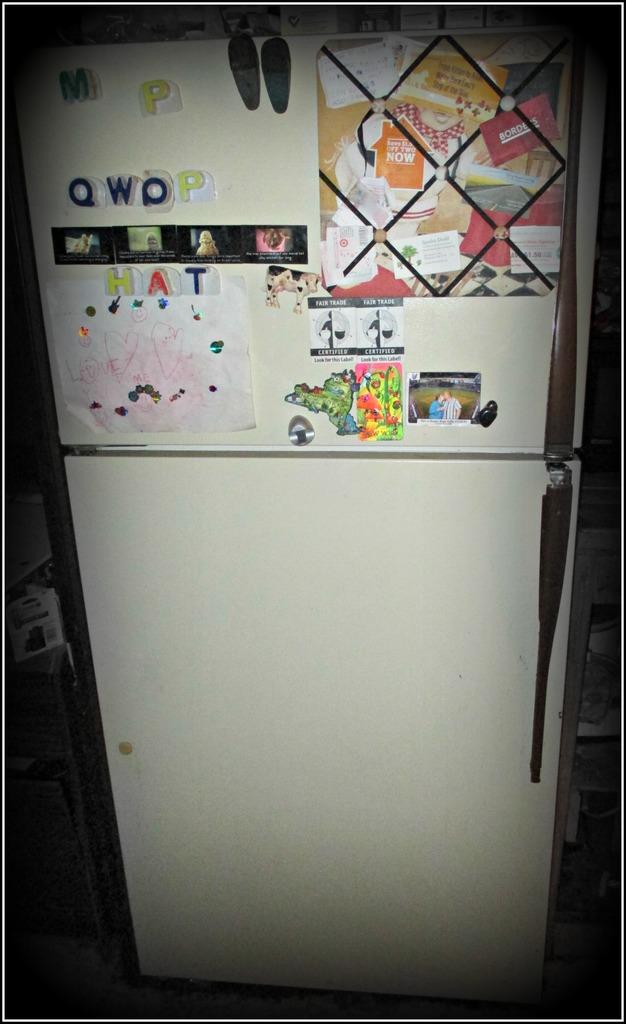What letters are the alphabet magnets on the fridge?
Offer a terse response. Q,w,o,p,m,h,a,t. What do the two stickers in the center say?
Your response must be concise. Fair trade certified. 